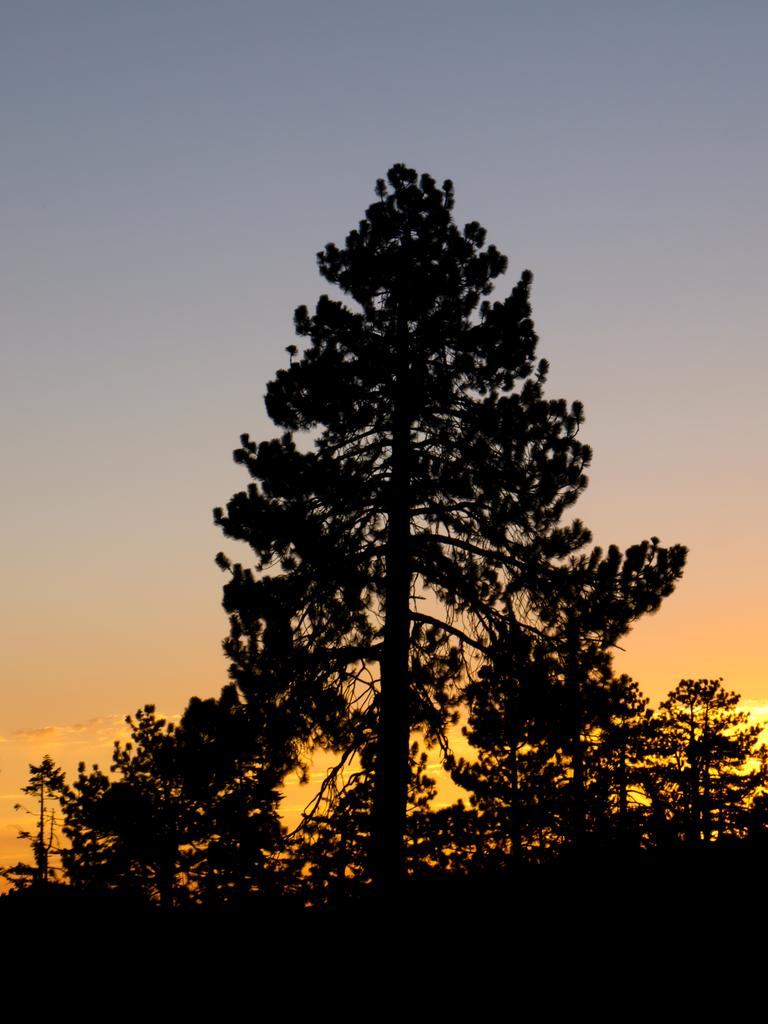What type of vegetation can be seen in the image? There is a group of trees in the image. What is visible in the background of the image? The sky is visible in the background of the image. How would you describe the sky's appearance in the image? The sky appears cloudy in the image. Can you see any snakes slithering among the trees in the image? There are no snakes visible in the image; it only features a group of trees and a cloudy sky. Is there any coal present in the image? There is no coal present in the image. 